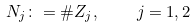Convert formula to latex. <formula><loc_0><loc_0><loc_500><loc_500>N _ { j } \colon = \# Z _ { j } , \quad j = 1 , 2</formula> 